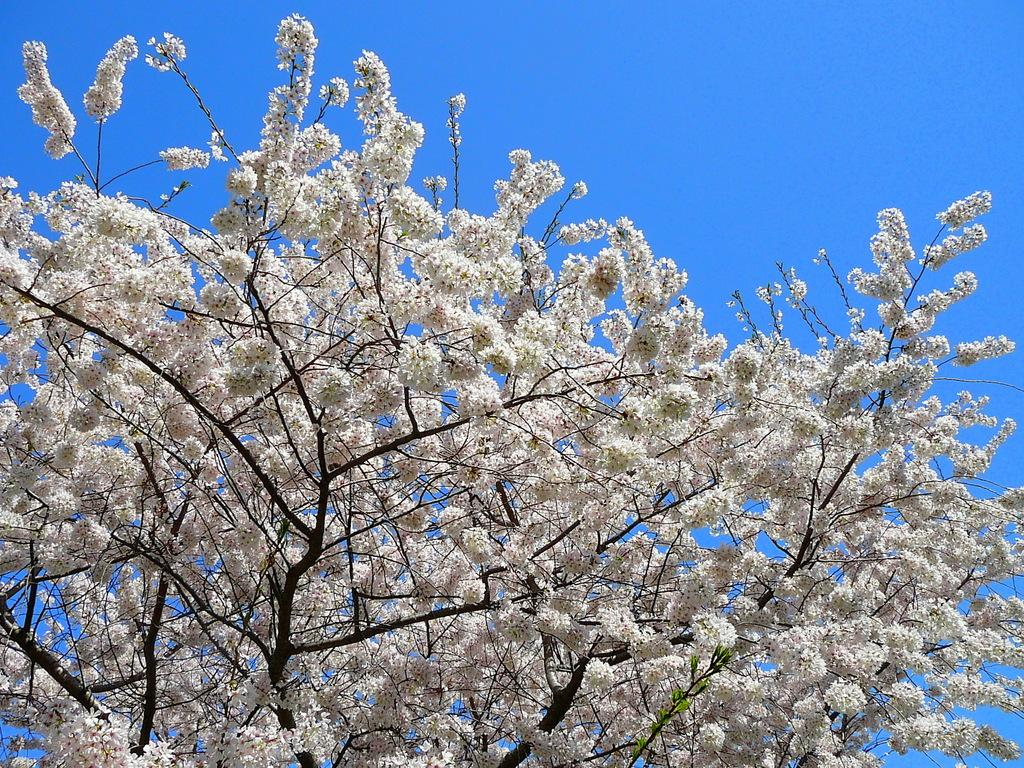What is the main subject in the center of the image? There is a tree in the center of the image. What can be seen on the tree? The tree has flowers on it. What color are the flowers on the tree? The flowers on the tree are white in color. Can you see a ticket hanging from the tree in the image? No, there is no ticket present in the image. Is there an ear attached to one of the flowers on the tree? No, there is no ear present in the image. 